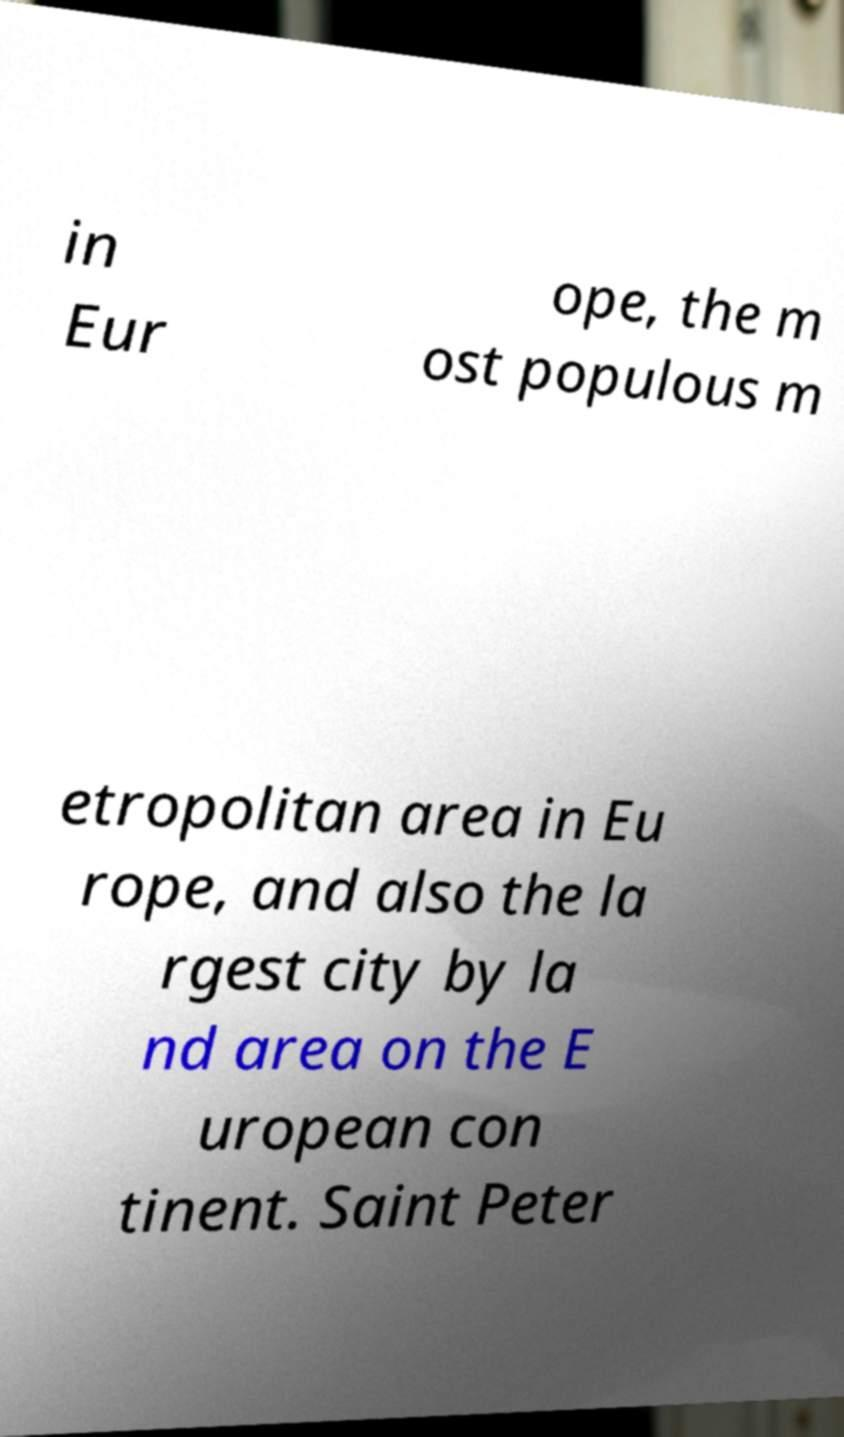Can you accurately transcribe the text from the provided image for me? in Eur ope, the m ost populous m etropolitan area in Eu rope, and also the la rgest city by la nd area on the E uropean con tinent. Saint Peter 